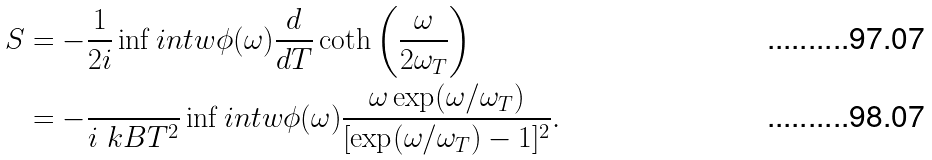Convert formula to latex. <formula><loc_0><loc_0><loc_500><loc_500>S & = - \frac { 1 } { 2 i } \inf i n t w \phi ( \omega ) \frac { d } { d T } \coth \left ( \frac { \omega } { 2 \omega _ { T } } \right ) \\ & = - \frac { } { i \ k B T ^ { 2 } } \inf i n t w \phi ( \omega ) \frac { \omega \exp ( \omega / \omega _ { T } ) } { [ \exp ( \omega / \omega _ { T } ) - 1 ] ^ { 2 } } .</formula> 